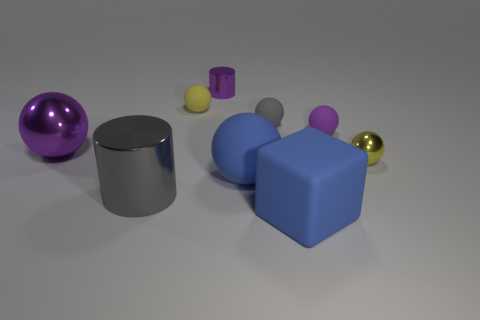Subtract all yellow spheres. How many spheres are left? 4 Subtract all yellow rubber spheres. How many spheres are left? 5 Subtract all gray spheres. Subtract all gray cylinders. How many spheres are left? 5 Subtract all cubes. How many objects are left? 8 Add 2 tiny purple matte things. How many tiny purple matte things exist? 3 Subtract 1 purple cylinders. How many objects are left? 8 Subtract all small yellow objects. Subtract all tiny cylinders. How many objects are left? 6 Add 8 big purple metallic balls. How many big purple metallic balls are left? 9 